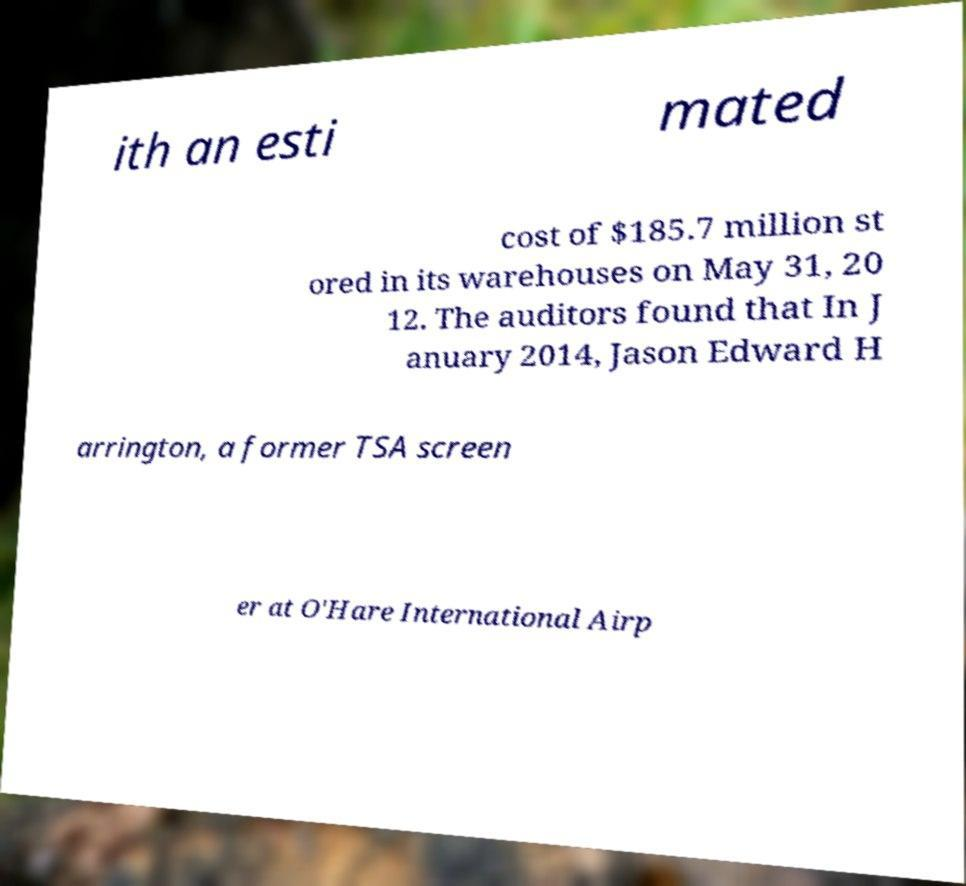Can you accurately transcribe the text from the provided image for me? ith an esti mated cost of $185.7 million st ored in its warehouses on May 31, 20 12. The auditors found that In J anuary 2014, Jason Edward H arrington, a former TSA screen er at O'Hare International Airp 